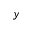Convert formula to latex. <formula><loc_0><loc_0><loc_500><loc_500>y</formula> 